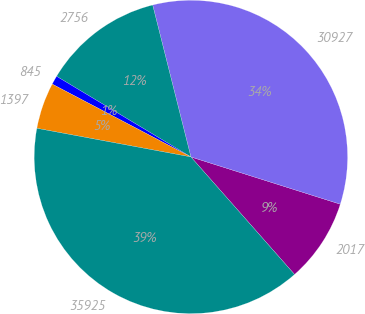Convert chart. <chart><loc_0><loc_0><loc_500><loc_500><pie_chart><fcel>2017<fcel>30927<fcel>2756<fcel>845<fcel>1397<fcel>35925<nl><fcel>8.62%<fcel>33.8%<fcel>12.47%<fcel>0.91%<fcel>4.77%<fcel>39.43%<nl></chart> 